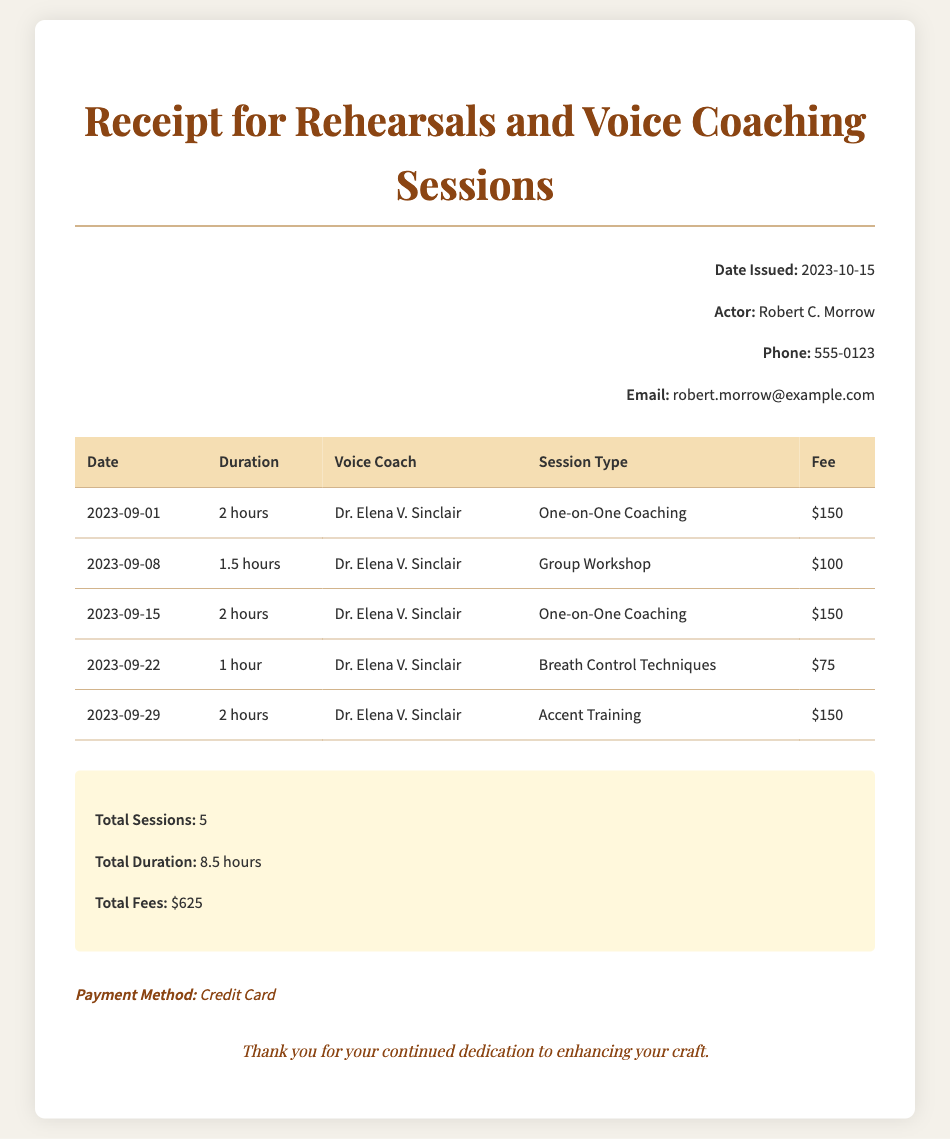what is the name of the voice coach? The voice coach's name is listed in each session, and the name provided is Dr. Elena V. Sinclair.
Answer: Dr. Elena V. Sinclair how many hours was the longest session? The longest session listed in the document is 2 hours, found in multiple instances.
Answer: 2 hours what is the total amount charged for the sessions? The total fees are calculated by adding the fees for all sessions, which totals $625.
Answer: $625 on what date was the first coaching session? The first coaching session date is listed at the top of the session table, which is 2023-09-01.
Answer: 2023-09-01 how many one-on-one coaching sessions were held? There are two one-on-one coaching sessions in the table, specifically dated 2023-09-01 and 2023-09-15.
Answer: 2 what was the total duration of all sessions combined? The total duration is summarized at the end of the table and amounts to 8.5 hours.
Answer: 8.5 hours what payment method was used? The payment method is specifically mentioned in the document, and it states that a credit card was used.
Answer: Credit Card how many total sessions were conducted? The total number of sessions is indicated in the summary section, which states a total of 5 sessions.
Answer: 5 